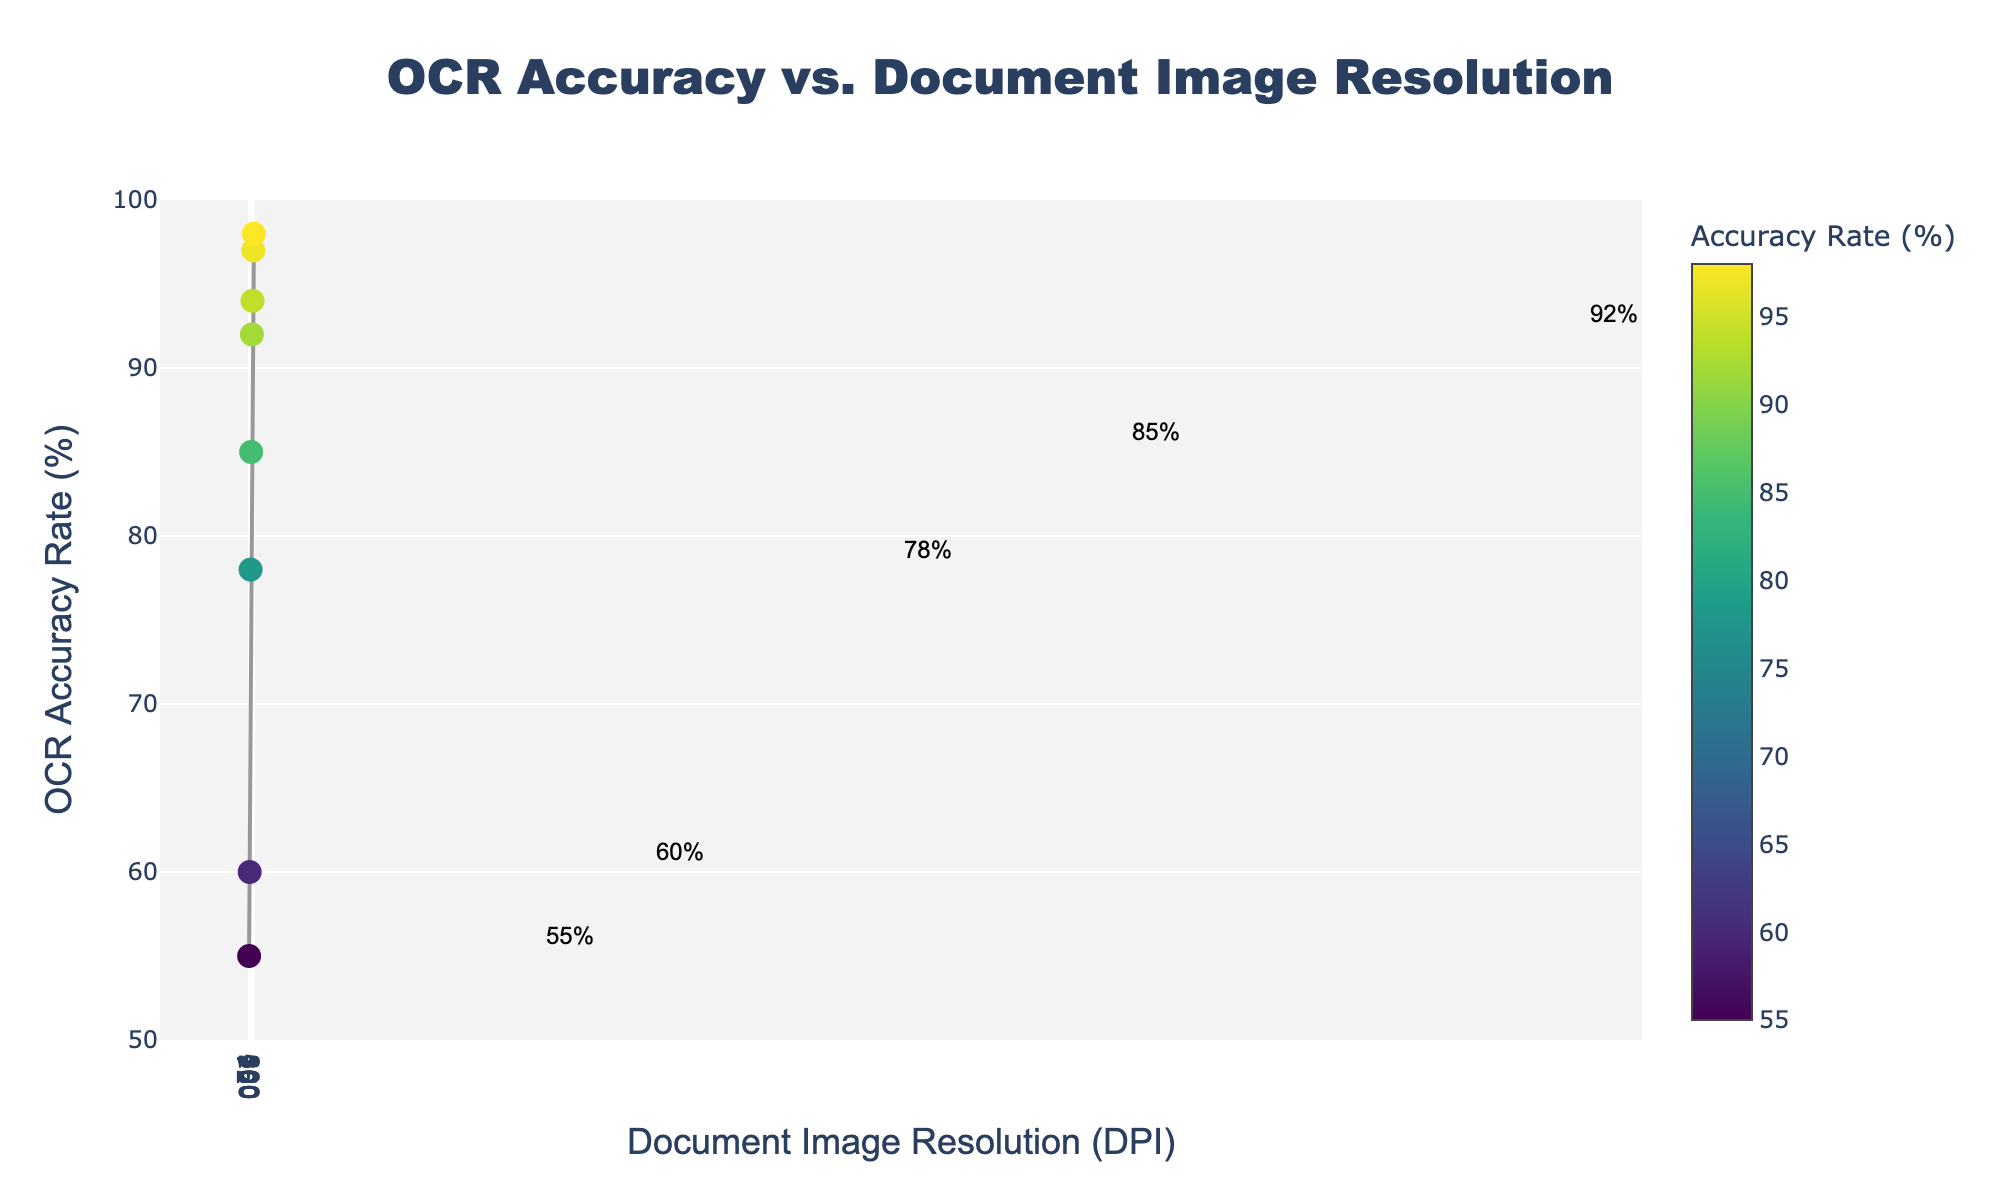What is the title of the scatter plot? The title is usually found at the top center of the plot. Reading the text there gives us the title.
Answer: OCR Accuracy vs. Document Image Resolution How many data points are displayed on the scatter plot? By counting the markers (dots) on the plot, we can determine the number of data points.
Answer: 8 What is the OCR accuracy rate for the document image resolution of 200 DPI? Locate the point on the plot where the x-axis value is 200 DPI and then read the corresponding y-axis value.
Answer: 85% Which document image resolution has the highest OCR accuracy rate and what is that rate? Find the data point with the highest y-axis value, then read its corresponding x-axis value.
Answer: 800 DPI, 98% What is the range of the OCR accuracy rates displayed on the plot? Identify the minimum and maximum y-axis values from the plotted data.
Answer: 55% to 98% How does the OCR accuracy rate change as the document image resolution increases from 72 DPI to 300 DPI? Observe the trend in the y-axis values as x-axis values increase from 72 DPI to 300 DPI. The OCR accuracy rate increases consistently.
Answer: It increases Calculate the average OCR accuracy rate for document image resolutions of 72, 96, and 150 DPI. Find the y-axis values for x-axis values 72, 96, and 150 DPI, then calculate their average. (55 + 60 + 78) / 3 = 64.33%
Answer: 64.33% Which two consecutive document image resolutions show the largest increase in OCR accuracy rate? Calculate the differences in OCR accuracy rate between consecutive resolutions and identify the largest increase. The biggest jump is from 96 DPI (60%) to 150 DPI (78%), which is an increase of 18%.
Answer: From 96 to 150 DPI Why is the x-axis labeled with document image resolution values but in a logarithmic scale? A logarithmic scale is used to better visualize data where values span several orders of magnitude, as shown in the spread of the DPI values.
Answer: To better visualize data spanning multiple orders of magnitude 